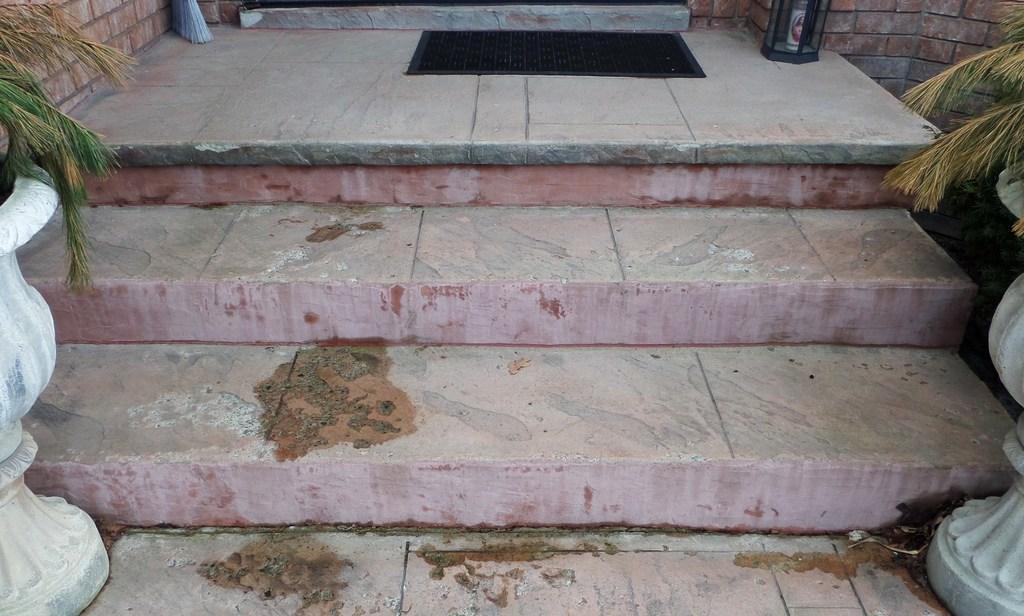Describe this image in one or two sentences. This image is taken outdoors. At the bottom of the image there is a flower. In the middle of the image there are a few stairs and there is a mat on the floor. In the background there is a wall. On the left and right sides of the image there are two pots with plants. 